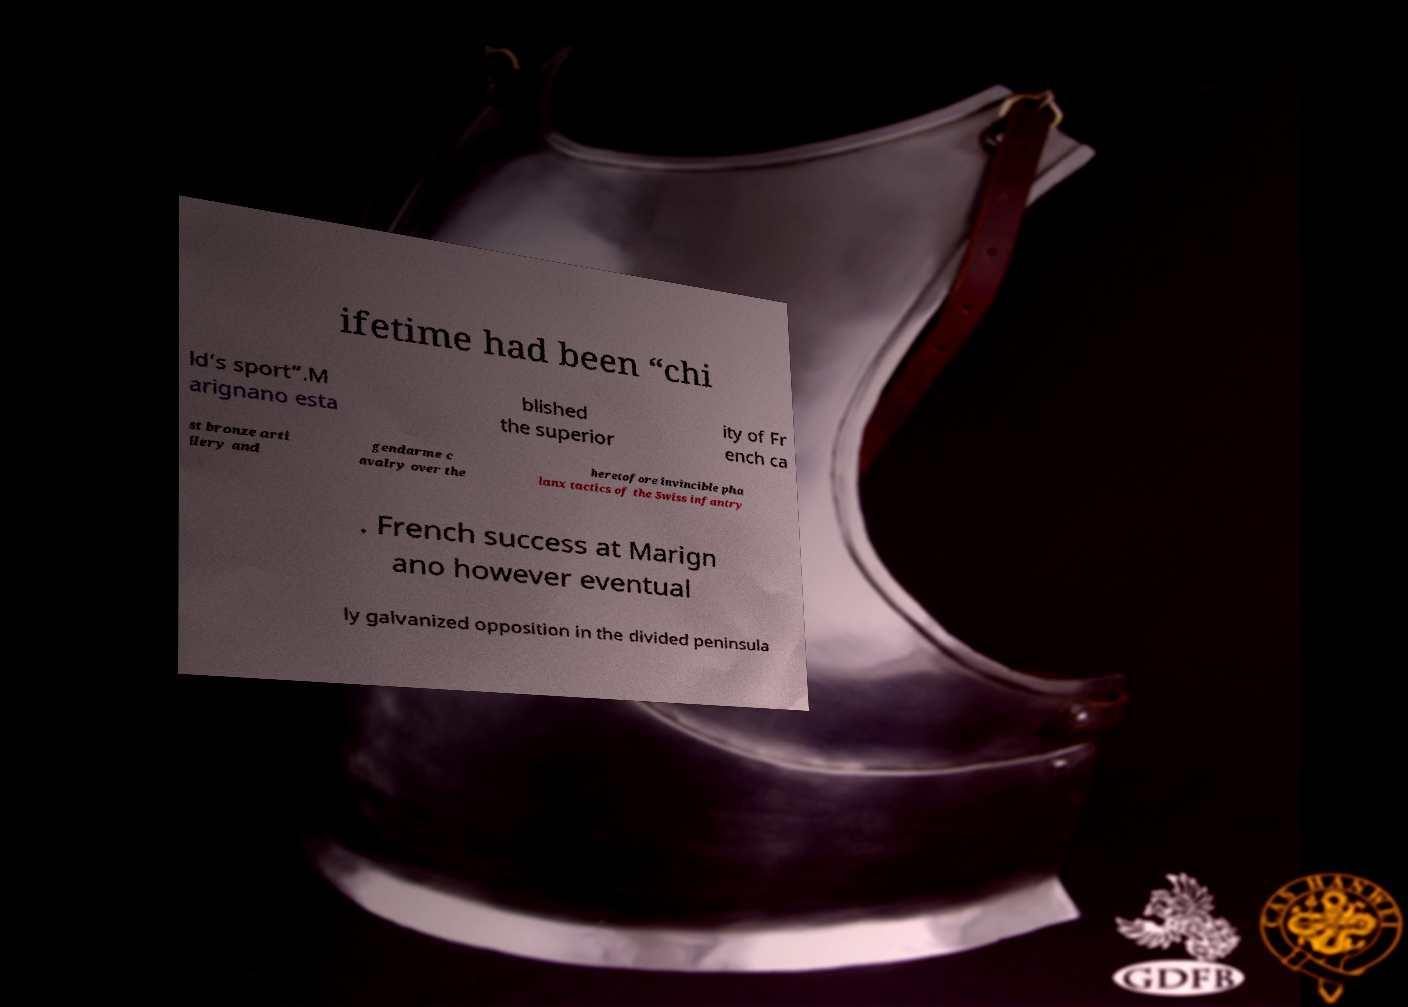For documentation purposes, I need the text within this image transcribed. Could you provide that? ifetime had been “chi ld’s sport”.M arignano esta blished the superior ity of Fr ench ca st bronze arti llery and gendarme c avalry over the heretofore invincible pha lanx tactics of the Swiss infantry . French success at Marign ano however eventual ly galvanized opposition in the divided peninsula 